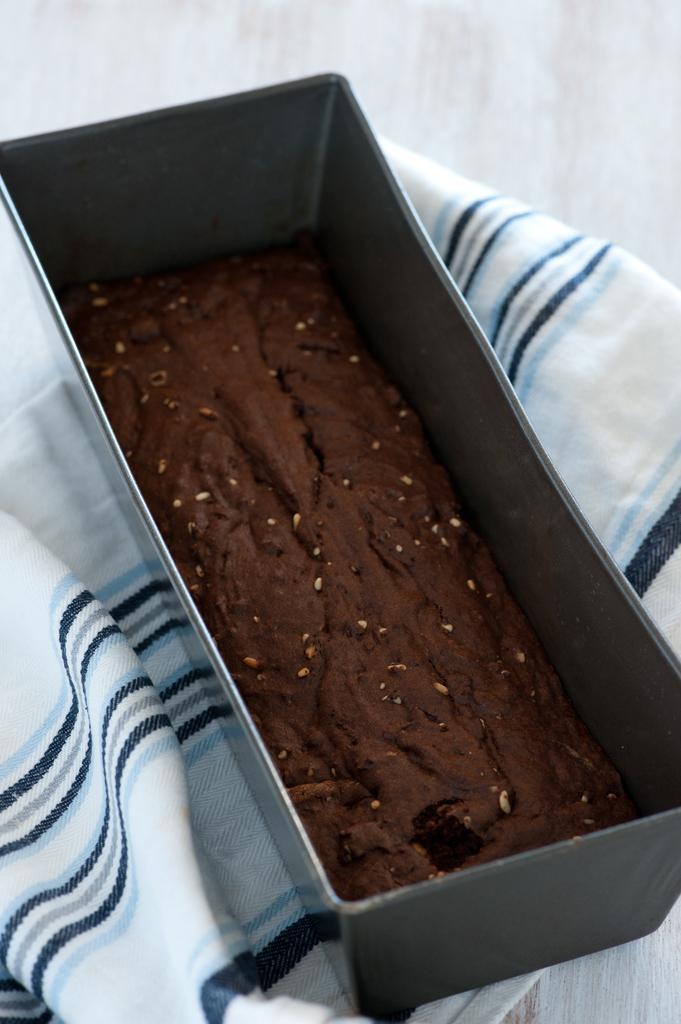Can you describe this image briefly? There is a tray with cake. And the tray is on a white and blue color cloth. In the back there is a wall. 